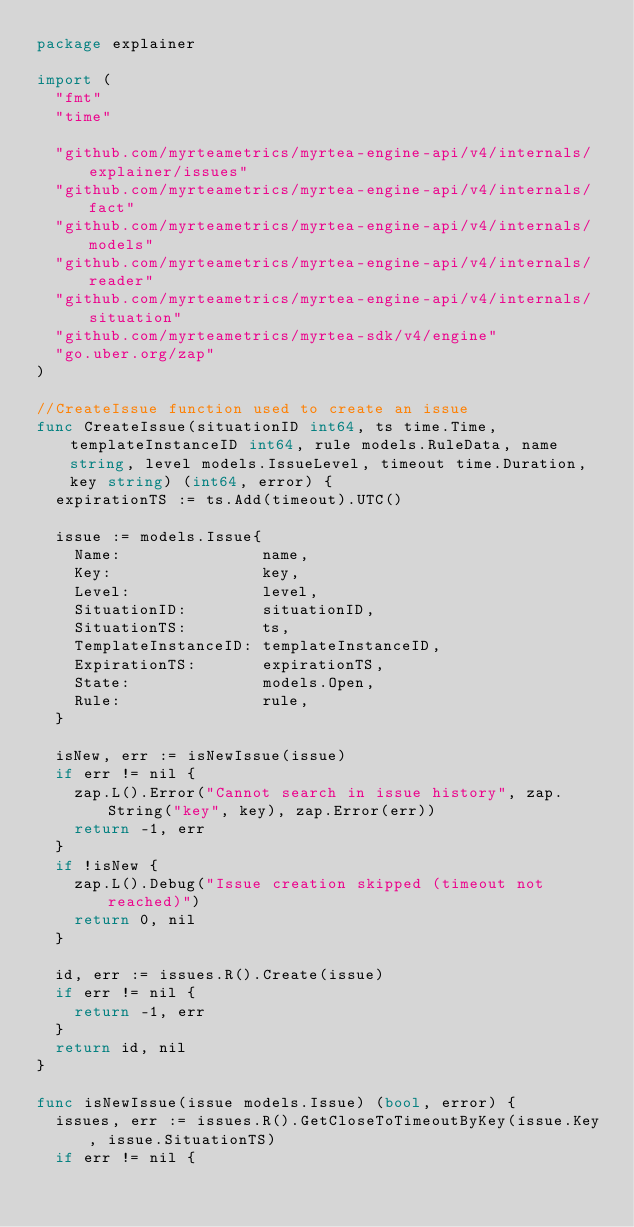<code> <loc_0><loc_0><loc_500><loc_500><_Go_>package explainer

import (
	"fmt"
	"time"

	"github.com/myrteametrics/myrtea-engine-api/v4/internals/explainer/issues"
	"github.com/myrteametrics/myrtea-engine-api/v4/internals/fact"
	"github.com/myrteametrics/myrtea-engine-api/v4/internals/models"
	"github.com/myrteametrics/myrtea-engine-api/v4/internals/reader"
	"github.com/myrteametrics/myrtea-engine-api/v4/internals/situation"
	"github.com/myrteametrics/myrtea-sdk/v4/engine"
	"go.uber.org/zap"
)

//CreateIssue function used to create an issue
func CreateIssue(situationID int64, ts time.Time, templateInstanceID int64, rule models.RuleData, name string, level models.IssueLevel, timeout time.Duration, key string) (int64, error) {
	expirationTS := ts.Add(timeout).UTC()

	issue := models.Issue{
		Name:               name,
		Key:                key,
		Level:              level,
		SituationID:        situationID,
		SituationTS:        ts,
		TemplateInstanceID: templateInstanceID,
		ExpirationTS:       expirationTS,
		State:              models.Open,
		Rule:               rule,
	}

	isNew, err := isNewIssue(issue)
	if err != nil {
		zap.L().Error("Cannot search in issue history", zap.String("key", key), zap.Error(err))
		return -1, err
	}
	if !isNew {
		zap.L().Debug("Issue creation skipped (timeout not reached)")
		return 0, nil
	}

	id, err := issues.R().Create(issue)
	if err != nil {
		return -1, err
	}
	return id, nil
}

func isNewIssue(issue models.Issue) (bool, error) {
	issues, err := issues.R().GetCloseToTimeoutByKey(issue.Key, issue.SituationTS)
	if err != nil {</code> 